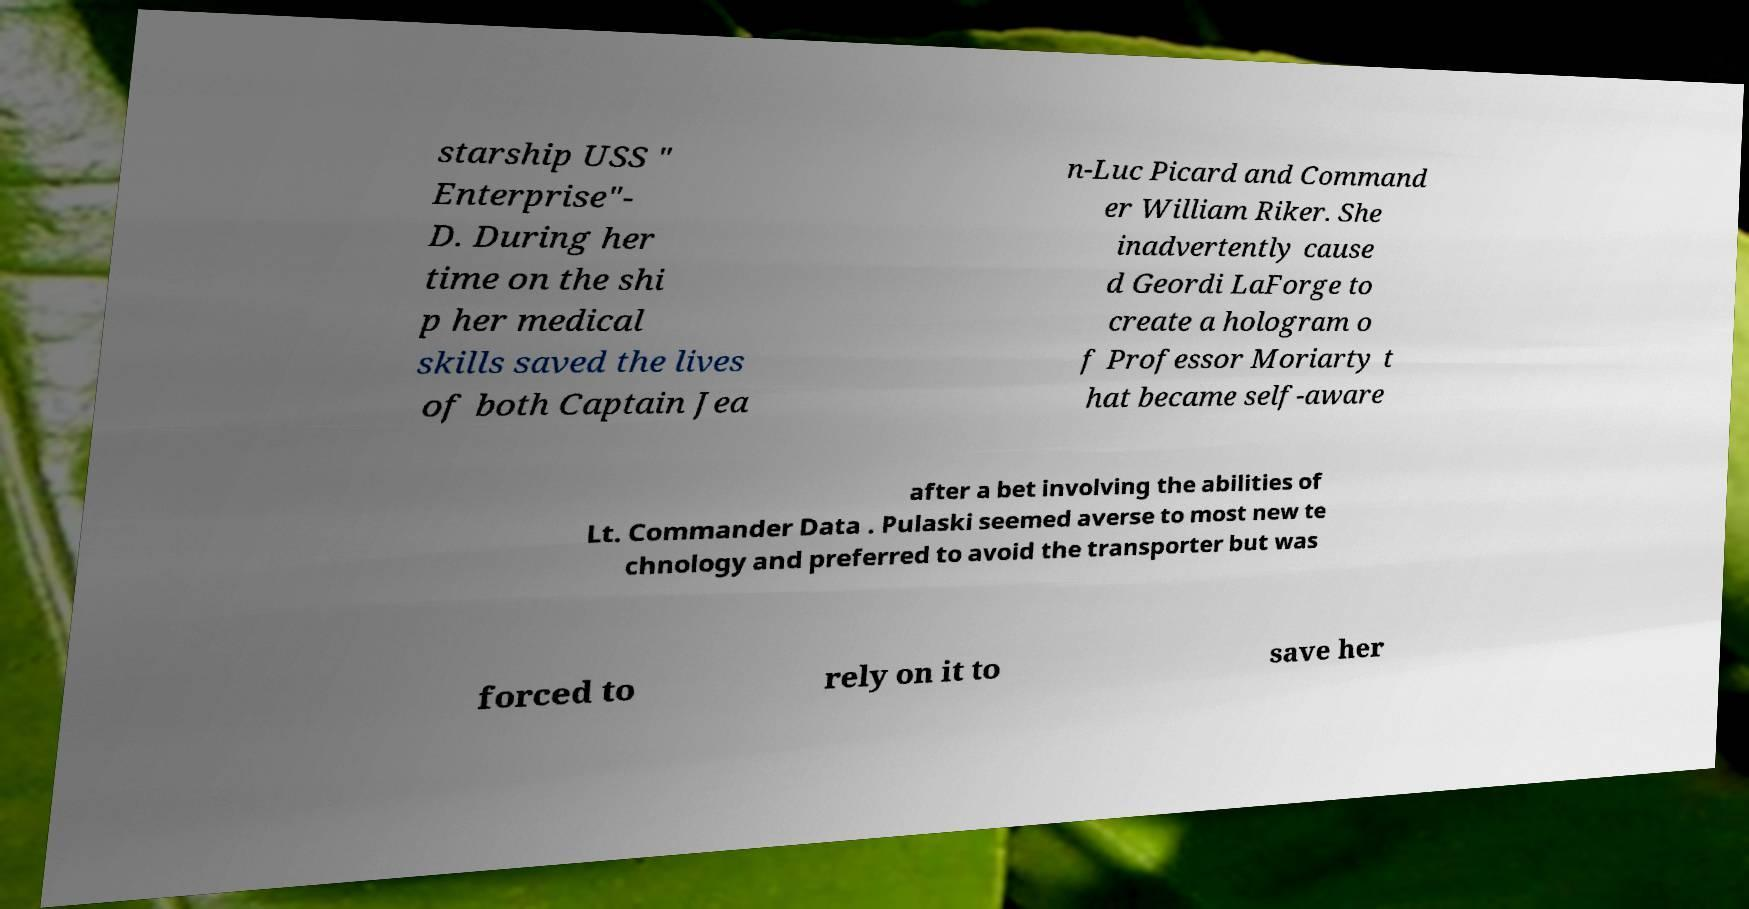I need the written content from this picture converted into text. Can you do that? starship USS " Enterprise"- D. During her time on the shi p her medical skills saved the lives of both Captain Jea n-Luc Picard and Command er William Riker. She inadvertently cause d Geordi LaForge to create a hologram o f Professor Moriarty t hat became self-aware after a bet involving the abilities of Lt. Commander Data . Pulaski seemed averse to most new te chnology and preferred to avoid the transporter but was forced to rely on it to save her 